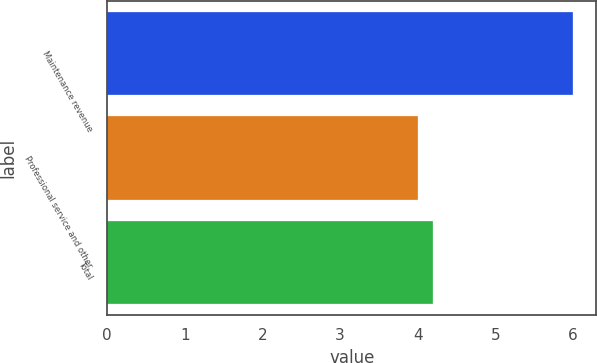Convert chart to OTSL. <chart><loc_0><loc_0><loc_500><loc_500><bar_chart><fcel>Maintenance revenue<fcel>Professional service and other<fcel>Total<nl><fcel>6<fcel>4<fcel>4.2<nl></chart> 